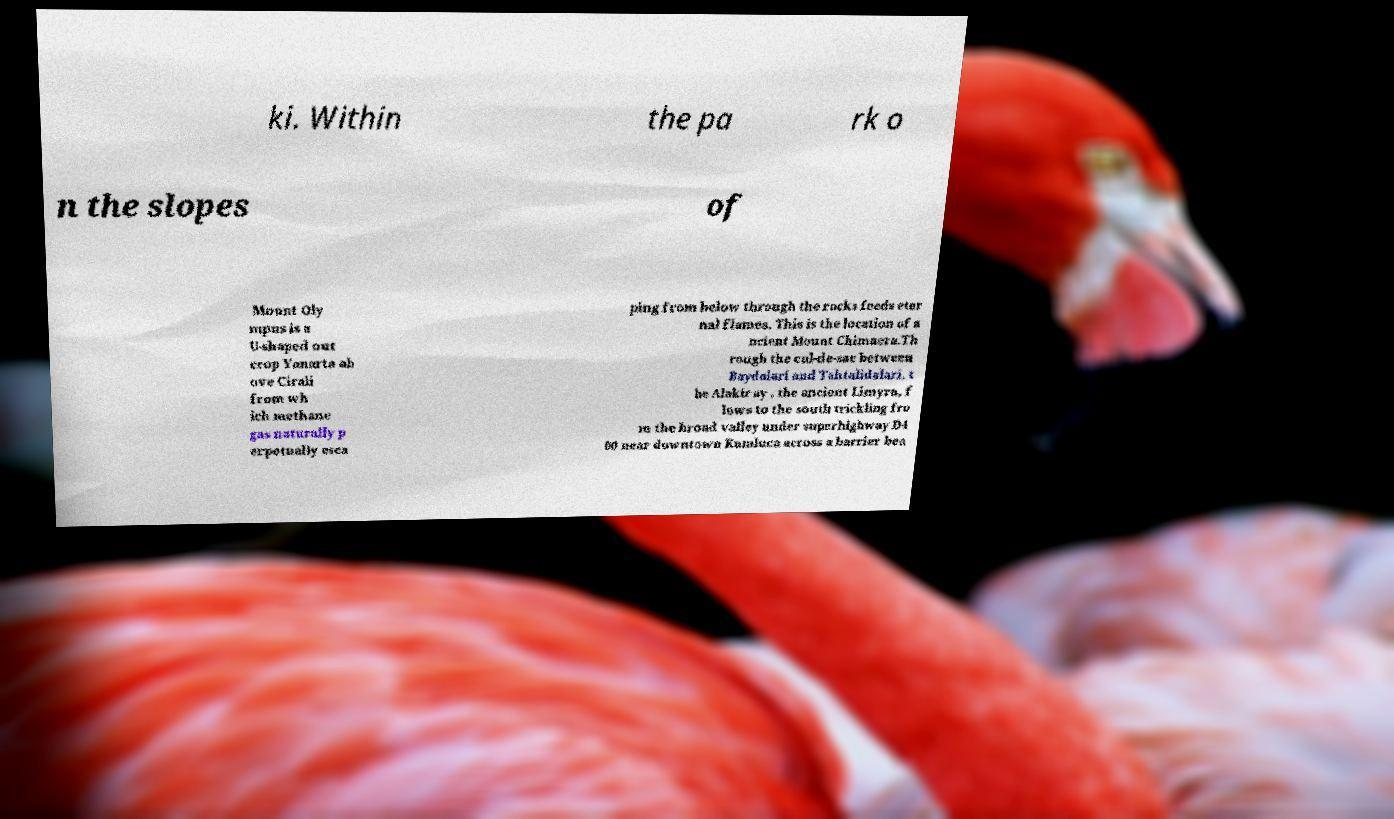Could you extract and type out the text from this image? ki. Within the pa rk o n the slopes of Mount Oly mpus is a U-shaped out crop Yanarta ab ove Cirali from wh ich methane gas naturally p erpetually esca ping from below through the rocks feeds eter nal flames. This is the location of a ncient Mount Chimaera.Th rough the cul-de-sac between Baydalari and Tahtalidalari, t he Alakir ay , the ancient Limyra, f lows to the south trickling fro m the broad valley under superhighway D4 00 near downtown Kumluca across a barrier bea 